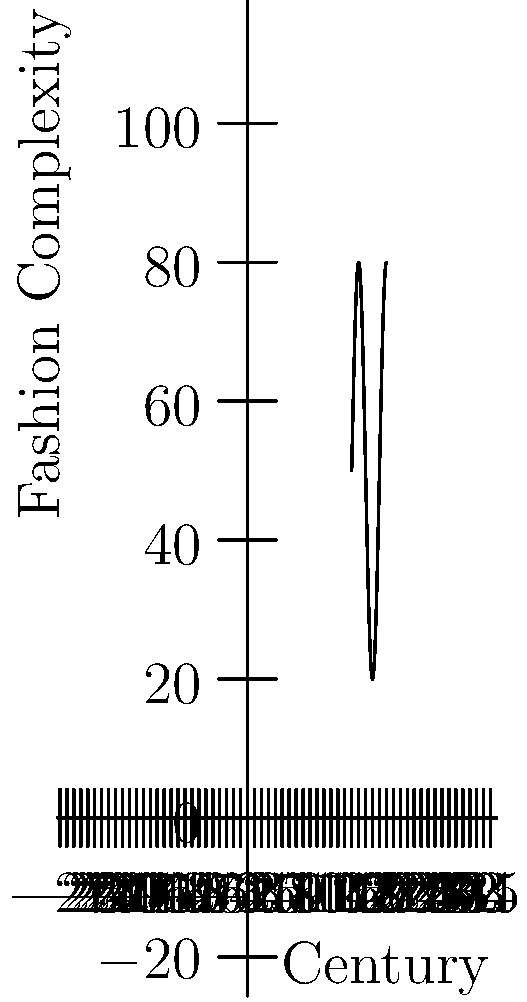Based on the timeline of aristocratic fashion trends shown in the graph, which era appears to have had the most complex and elaborate clothing styles? What factors might have contributed to this peak in fashion complexity? To answer this question, we need to analyze the graph and consider historical context:

1. The y-axis represents fashion complexity, with higher values indicating more elaborate styles.

2. Examining the curve, we can see that it peaks during the Georgian era (18th century).

3. The Georgian era (1714-1837) was known for its extravagant and ornate fashion, particularly in the latter half of the 18th century.

4. Factors contributing to this peak in fashion complexity:
   a) Economic prosperity: The Industrial Revolution began, leading to increased wealth among the upper classes.
   b) Social competition: Elaborate clothing was a way to display status and wealth.
   c) Cultural influences: The Rococo and Neoclassical art movements influenced fashion.
   d) Technological advancements: Improvements in textile production and tailoring techniques allowed for more intricate designs.

5. The curve shows a decline in complexity after the Georgian era, likely due to:
   a) Changing social norms: The Victorian era brought more conservative values.
   b) Practical considerations: Simpler styles were more suitable for the increasingly urban lifestyle.

Therefore, the Georgian era represents the peak of fashion complexity in British aristocratic clothing styles during the period shown.
Answer: Georgian era; economic prosperity, social competition, cultural influences, and technological advancements. 